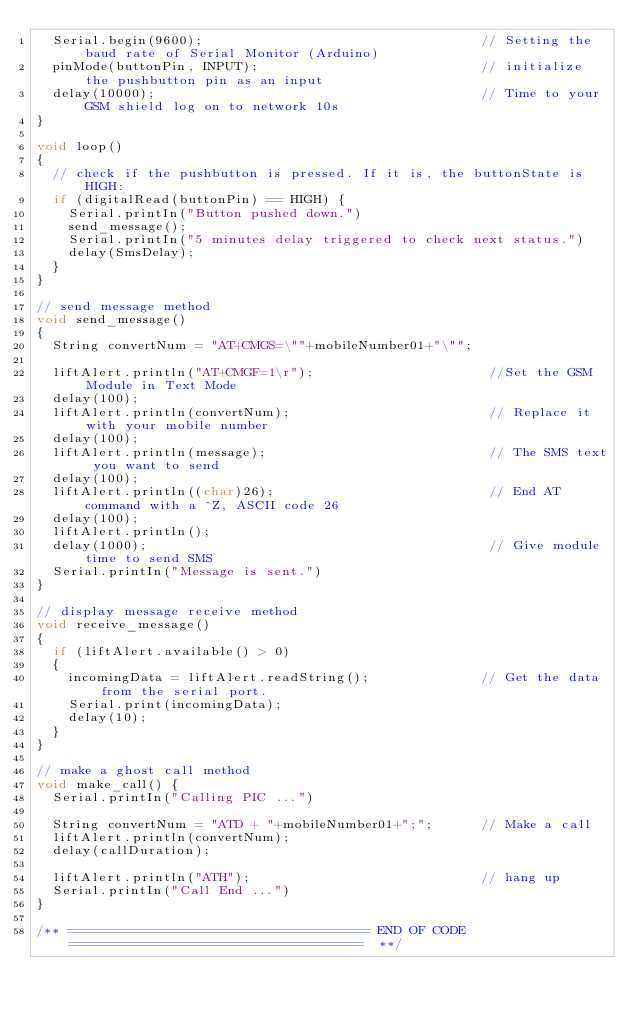Convert code to text. <code><loc_0><loc_0><loc_500><loc_500><_C++_>  Serial.begin(9600);                                   // Setting the baud rate of Serial Monitor (Arduino)
  pinMode(buttonPin, INPUT);                            // initialize the pushbutton pin as an input
  delay(10000);                                         // Time to your GSM shield log on to network 10s
}

void loop()
{
  // check if the pushbutton is pressed. If it is, the buttonState is HIGH:
  if (digitalRead(buttonPin) == HIGH) {
    Serial.printIn("Button pushed down.")
    send_message();
    Serial.printIn("5 minutes delay triggered to check next status.")
    delay(SmsDelay);
  }
}

// send message method
void send_message()
{
  String convertNum = "AT+CMGS=\""+mobileNumber01+"\"";

  liftAlert.println("AT+CMGF=1\r");                      //Set the GSM Module in Text Mode
  delay(100);
  liftAlert.println(convertNum);                         // Replace it with your mobile number
  delay(100);
  liftAlert.println(message);                            // The SMS text you want to send
  delay(100);
  liftAlert.println((char)26);                           // End AT command with a ^Z, ASCII code 26
  delay(100);
  liftAlert.println();
  delay(1000);                                           // Give module time to send SMS
  Serial.printIn("Message is sent.")
}

// display message receive method
void receive_message()
{
  if (liftAlert.available() > 0)
  {
    incomingData = liftAlert.readString();              // Get the data from the serial port.
    Serial.print(incomingData);
    delay(10);
  }
}

// make a ghost call method
void make_call() {
  Serial.printIn("Calling PIC ...")

  String convertNum = "ATD + "+mobileNumber01+";";      // Make a call
  liftAlert.println(convertNum);
  delay(callDuration);

  liftAlert.println("ATH");                             // hang up
  Serial.printIn("Call End ...")
}

/** ====================================== END OF CODE =====================================  **/</code> 